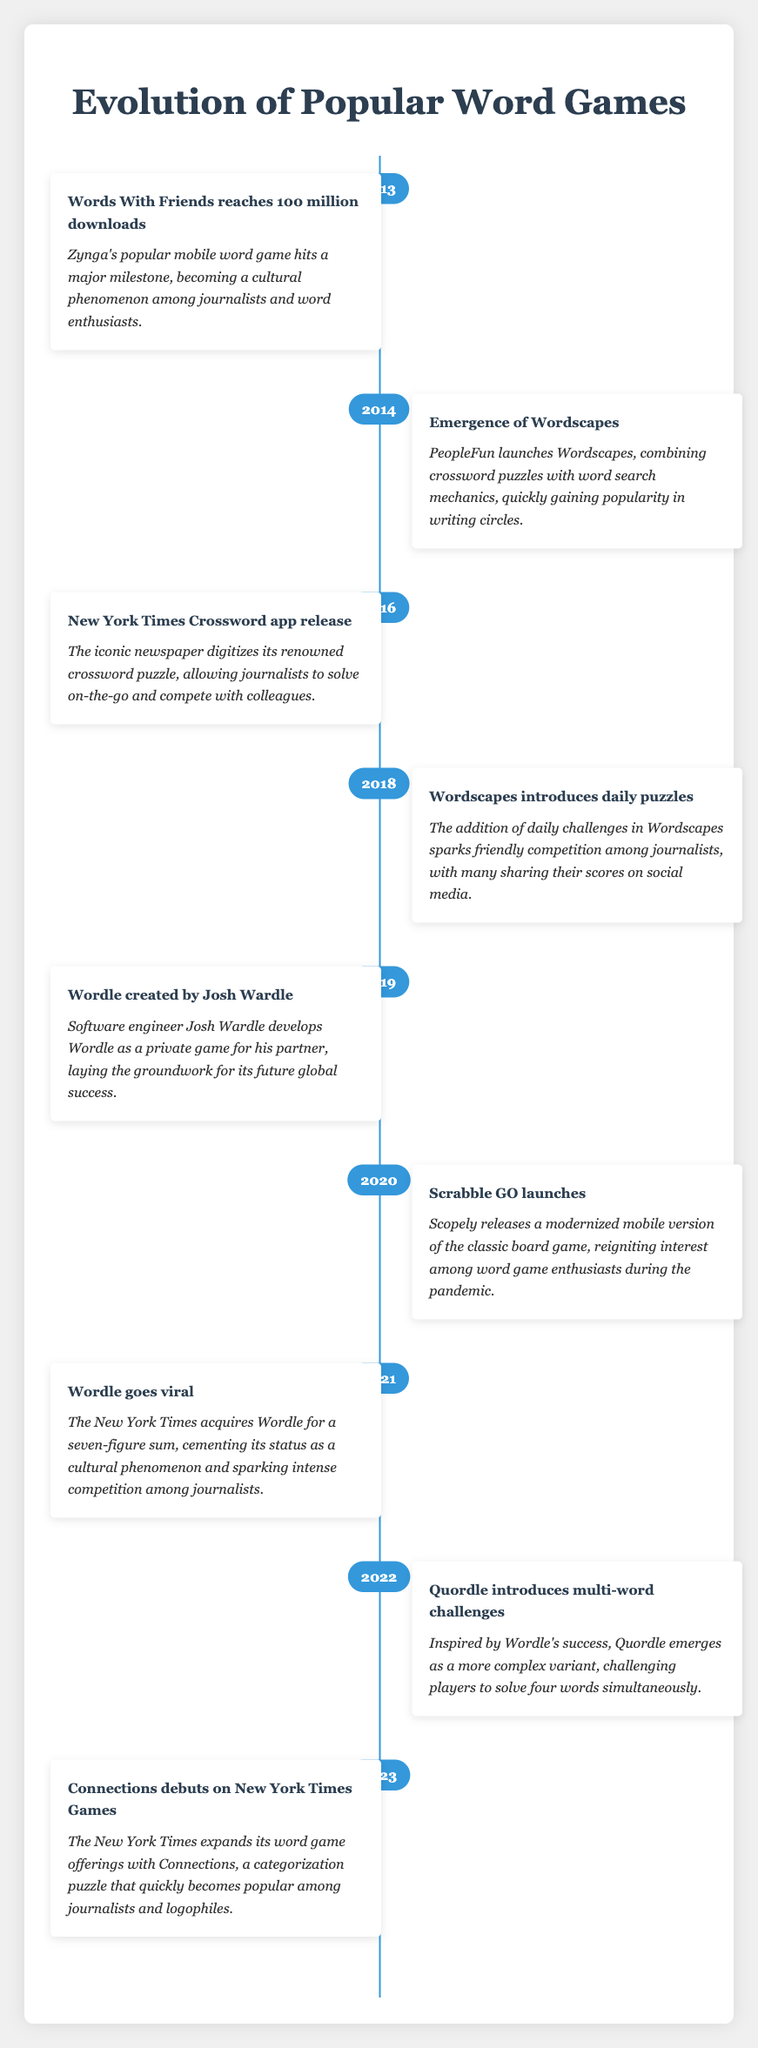What year did Words With Friends reach 100 million downloads? The table indicates that Words With Friends reached this milestone in 2013.
Answer: 2013 Which game was launched by PeopleFun in 2014? The timeline states that Wordscapes was launched by PeopleFun in 2014.
Answer: Wordscapes Is it true that a new version of Scrabble was released in 2020? Yes, the table confirms that Scrabble GO, a modernized mobile version, was launched in 2020.
Answer: Yes What significant event occurred in 2019 related to Wordle? In 2019, Wordle was created by Josh Wardle as a private game for his partner, marking its inception.
Answer: Wordle was created In which year did Wordle go viral? According to the timeline, Wordle went viral in 2021 after being acquired by The New York Times.
Answer: 2021 How many years passed between the release of Wordscapes and the introduction of daily puzzles in the game? Wordscapes was launched in 2014, and daily puzzles were introduced in 2018, which is 4 years apart.
Answer: 4 years Which two games were mentioned in relation to The New York Times and their expanding offerings in the timeline? The table lists the New York Times Crossword app and Connections as games related to The New York Times' offerings.
Answer: New York Times Crossword and Connections What is the difference in years between the launch of Scrabble GO and the creation of Wordle? Scrabble GO launched in 2020 and Wordle was created in 2019. The difference in years between these two events is 1 year.
Answer: 1 year Did Quordle emerge as a variant of a successful game in the timeline? Yes, the timeline notes that Quordle was inspired by the success of Wordle.
Answer: Yes 